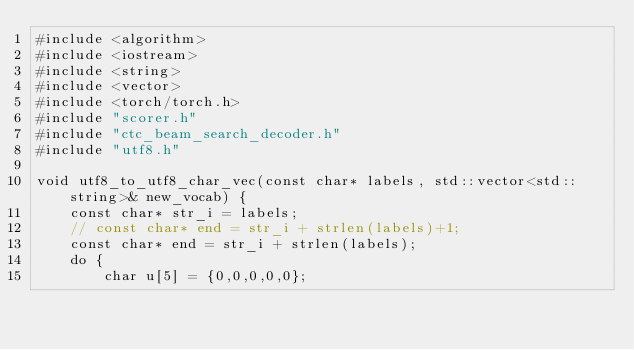<code> <loc_0><loc_0><loc_500><loc_500><_C++_>#include <algorithm>
#include <iostream>
#include <string>
#include <vector>
#include <torch/torch.h>
#include "scorer.h"
#include "ctc_beam_search_decoder.h"
#include "utf8.h"

void utf8_to_utf8_char_vec(const char* labels, std::vector<std::string>& new_vocab) {
    const char* str_i = labels;
    // const char* end = str_i + strlen(labels)+1;
    const char* end = str_i + strlen(labels);
    do {
        char u[5] = {0,0,0,0,0};</code> 